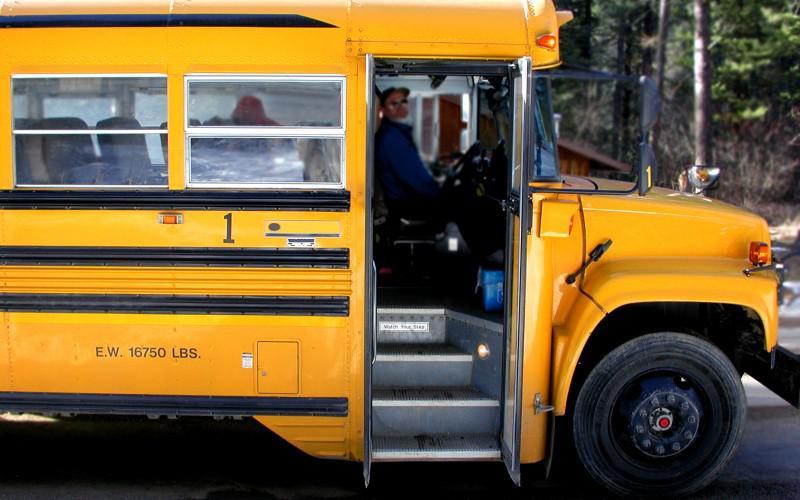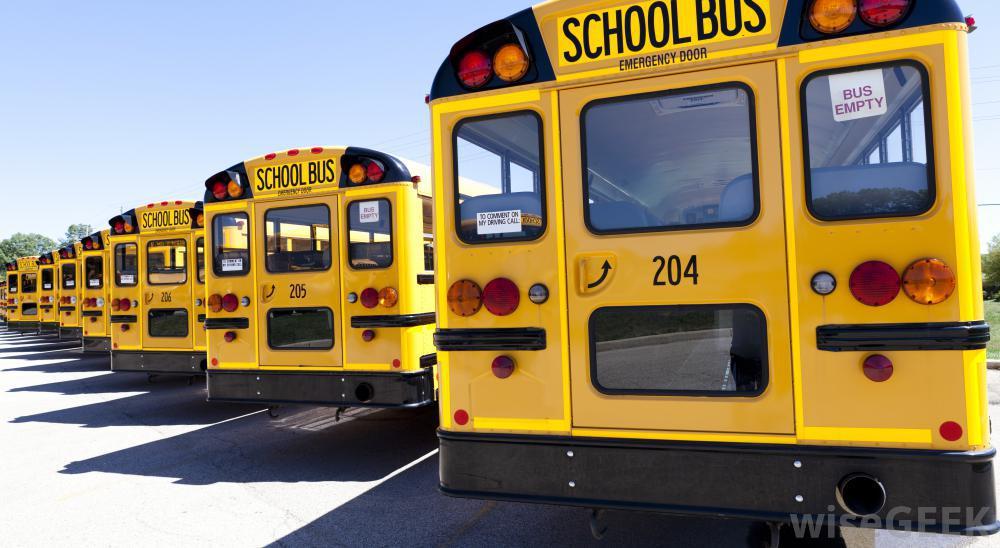The first image is the image on the left, the second image is the image on the right. Evaluate the accuracy of this statement regarding the images: "The school bus door is open and ready to accept passengers.". Is it true? Answer yes or no. Yes. The first image is the image on the left, the second image is the image on the right. Given the left and right images, does the statement "Each image shows a yellow school bus which has been damaged in an accident." hold true? Answer yes or no. No. 